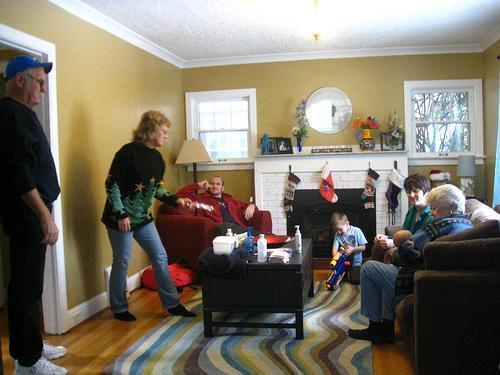How many people in the image are standing?
Give a very brief answer. 2. 